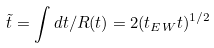Convert formula to latex. <formula><loc_0><loc_0><loc_500><loc_500>\tilde { t } = \int d t / R ( t ) = 2 ( t _ { E W } t ) ^ { 1 / 2 }</formula> 